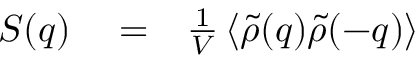Convert formula to latex. <formula><loc_0><loc_0><loc_500><loc_500>\begin{array} { r l r } { S ( q ) } & = } & { \frac { 1 } { V } \left \langle \tilde { \rho } ( q ) \tilde { \rho } ( - q ) \right \rangle } \end{array}</formula> 